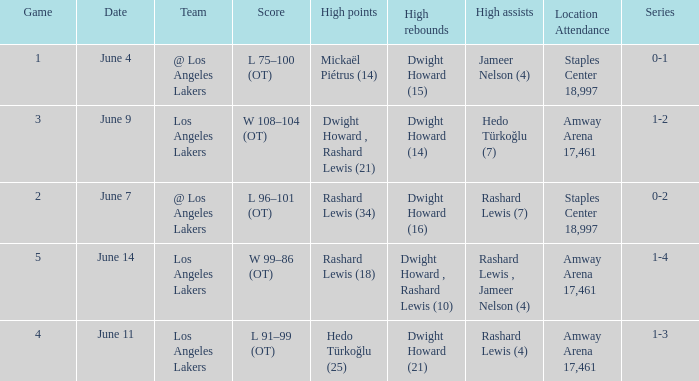What is High Points, when High Rebounds is "Dwight Howard (16)"? Rashard Lewis (34). 